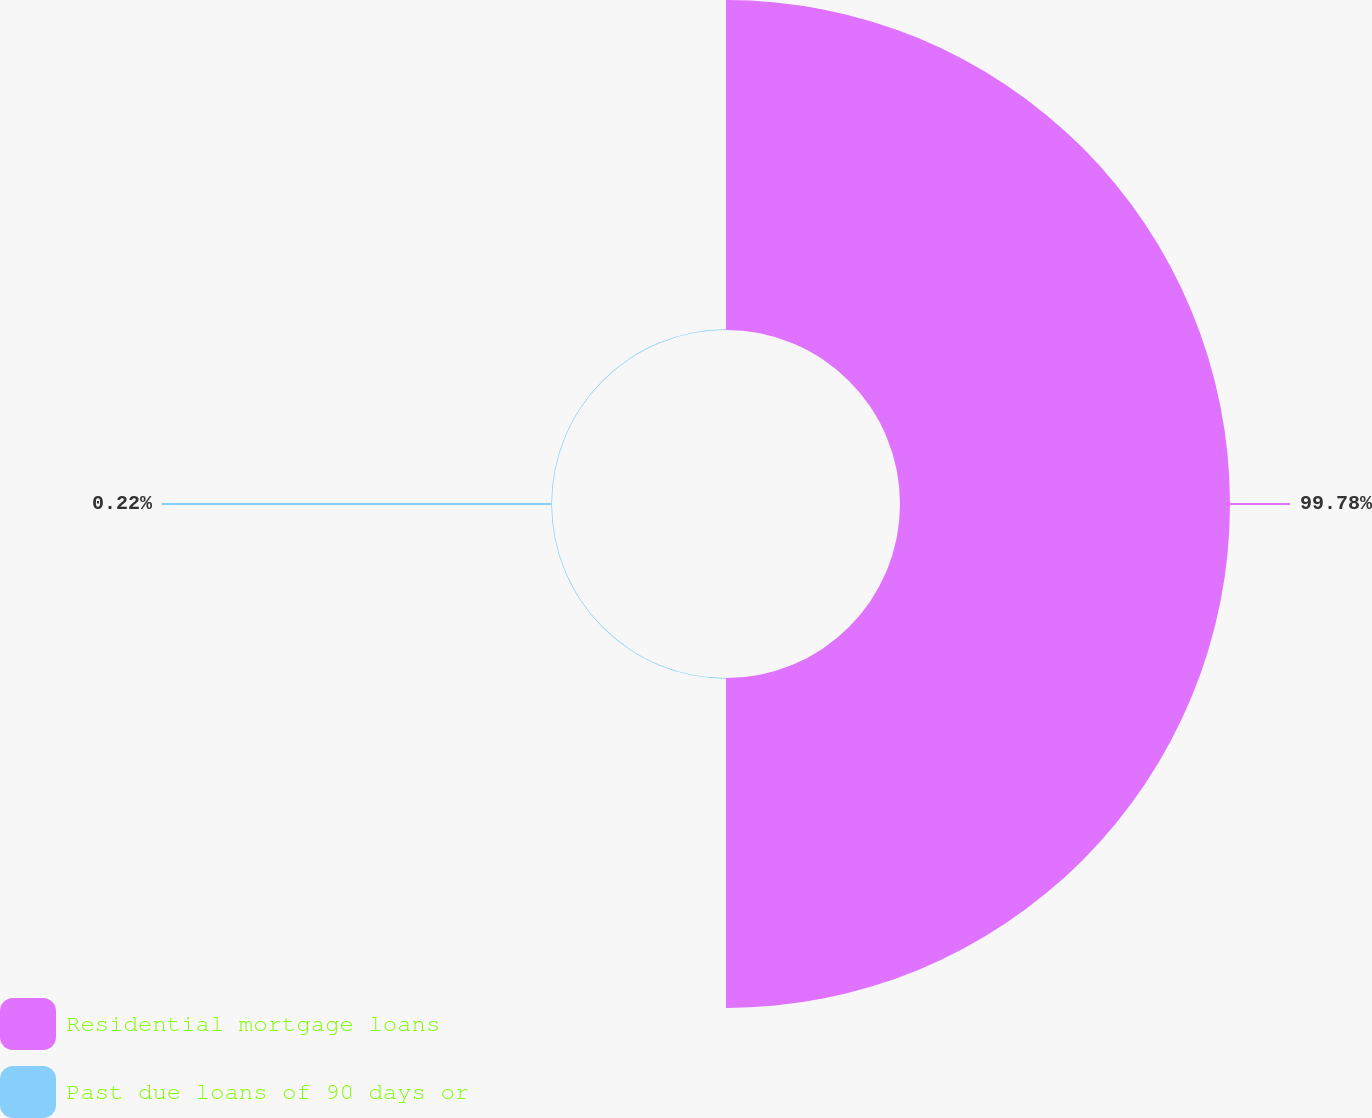Convert chart. <chart><loc_0><loc_0><loc_500><loc_500><pie_chart><fcel>Residential mortgage loans<fcel>Past due loans of 90 days or<nl><fcel>99.78%<fcel>0.22%<nl></chart> 